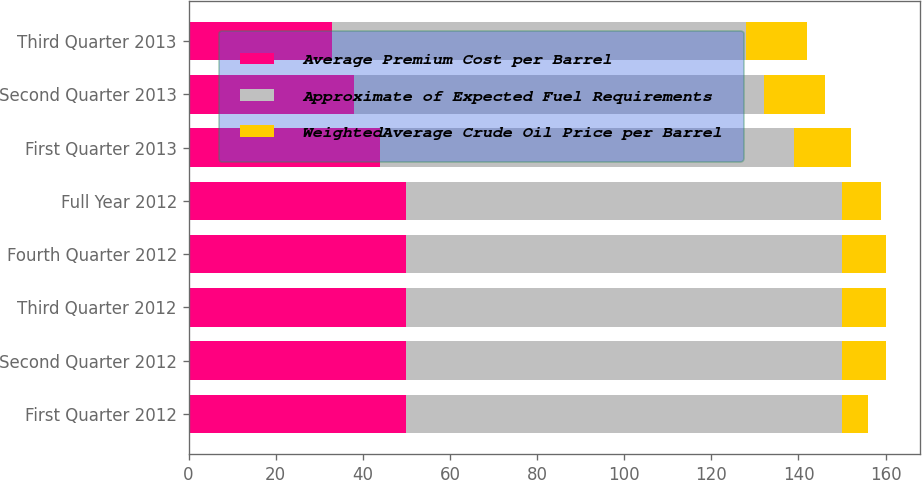Convert chart to OTSL. <chart><loc_0><loc_0><loc_500><loc_500><stacked_bar_chart><ecel><fcel>First Quarter 2012<fcel>Second Quarter 2012<fcel>Third Quarter 2012<fcel>Fourth Quarter 2012<fcel>Full Year 2012<fcel>First Quarter 2013<fcel>Second Quarter 2013<fcel>Third Quarter 2013<nl><fcel>Average Premium Cost per Barrel<fcel>50<fcel>50<fcel>50<fcel>50<fcel>50<fcel>44<fcel>38<fcel>33<nl><fcel>Approximate of Expected Fuel Requirements<fcel>100<fcel>100<fcel>100<fcel>100<fcel>100<fcel>95<fcel>94<fcel>95<nl><fcel>WeightedAverage Crude Oil Price per Barrel<fcel>6<fcel>10<fcel>10<fcel>10<fcel>9<fcel>13<fcel>14<fcel>14<nl></chart> 